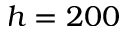Convert formula to latex. <formula><loc_0><loc_0><loc_500><loc_500>h = 2 0 0</formula> 